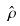Convert formula to latex. <formula><loc_0><loc_0><loc_500><loc_500>\hat { \rho }</formula> 